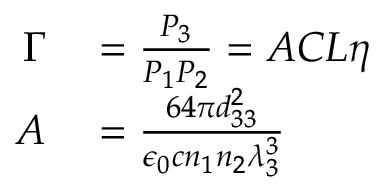Convert formula to latex. <formula><loc_0><loc_0><loc_500><loc_500>\begin{array} { r l } { \Gamma } & = \frac { P _ { 3 } } { P _ { 1 } P _ { 2 } } = A C L \eta } \\ { A } & = \frac { 6 4 \pi d _ { 3 3 } ^ { 2 } } { \epsilon _ { 0 } c n _ { 1 } n _ { 2 } \lambda _ { 3 } ^ { 3 } } } \end{array}</formula> 